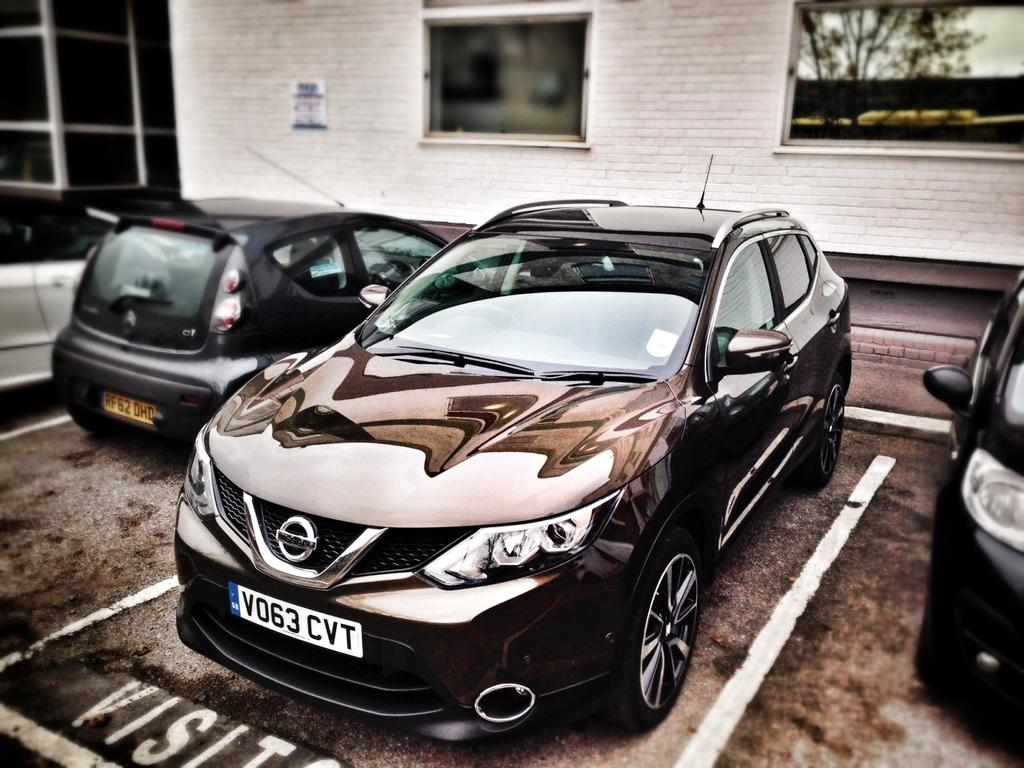What is present in the image that is used for transportation? There are vehicles parked in the image. Where are the vehicles parked in the image? The vehicles are parked in a parking place. What type of structure is visible in the image? There is a white-colored building visible in the image. What type of furniture can be seen in the image? There is no furniture present in the image. What is the mental state of the vehicles in the image? The vehicles do not have a mental state, as they are inanimate objects. 